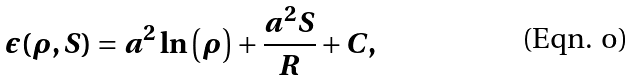<formula> <loc_0><loc_0><loc_500><loc_500>\epsilon ( \rho , S ) = a ^ { 2 } \ln \left ( \rho \right ) + \frac { a ^ { 2 } S } { R } + C ,</formula> 